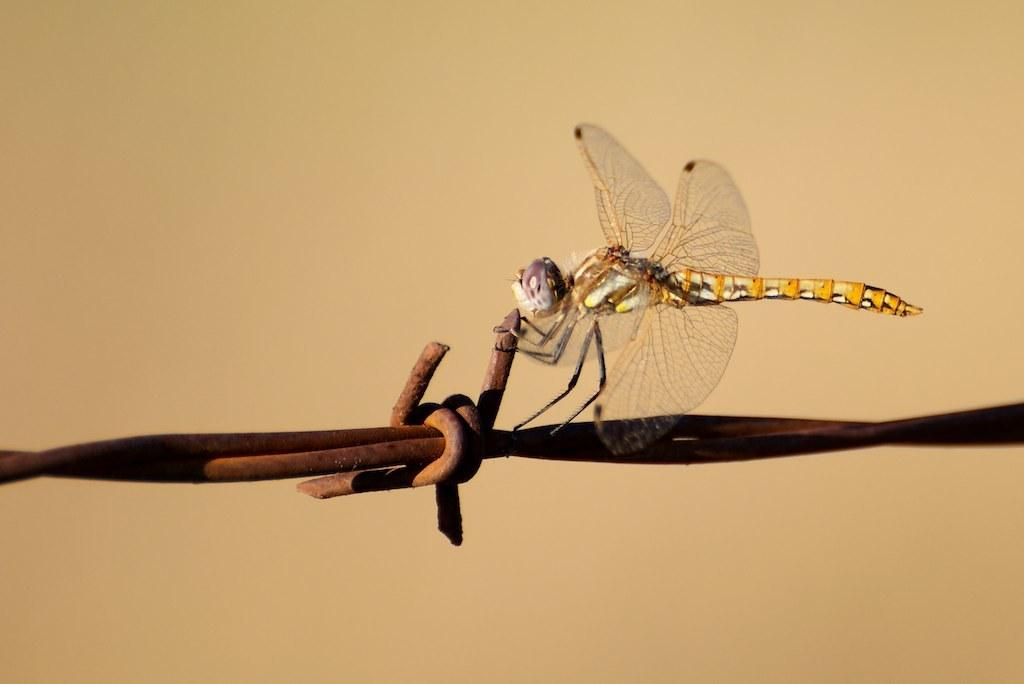What type of insect can be seen in the image? There is a dragonfly in the image. What kind of object made of iron is present in the image? There is an iron object in the image. What can be seen in the background of the image? There is a wall in the background of the image. How does the dragonfly participate in the fight scene in the image? There is no fight scene present in the image, and the dragonfly is not involved in any such activity. 